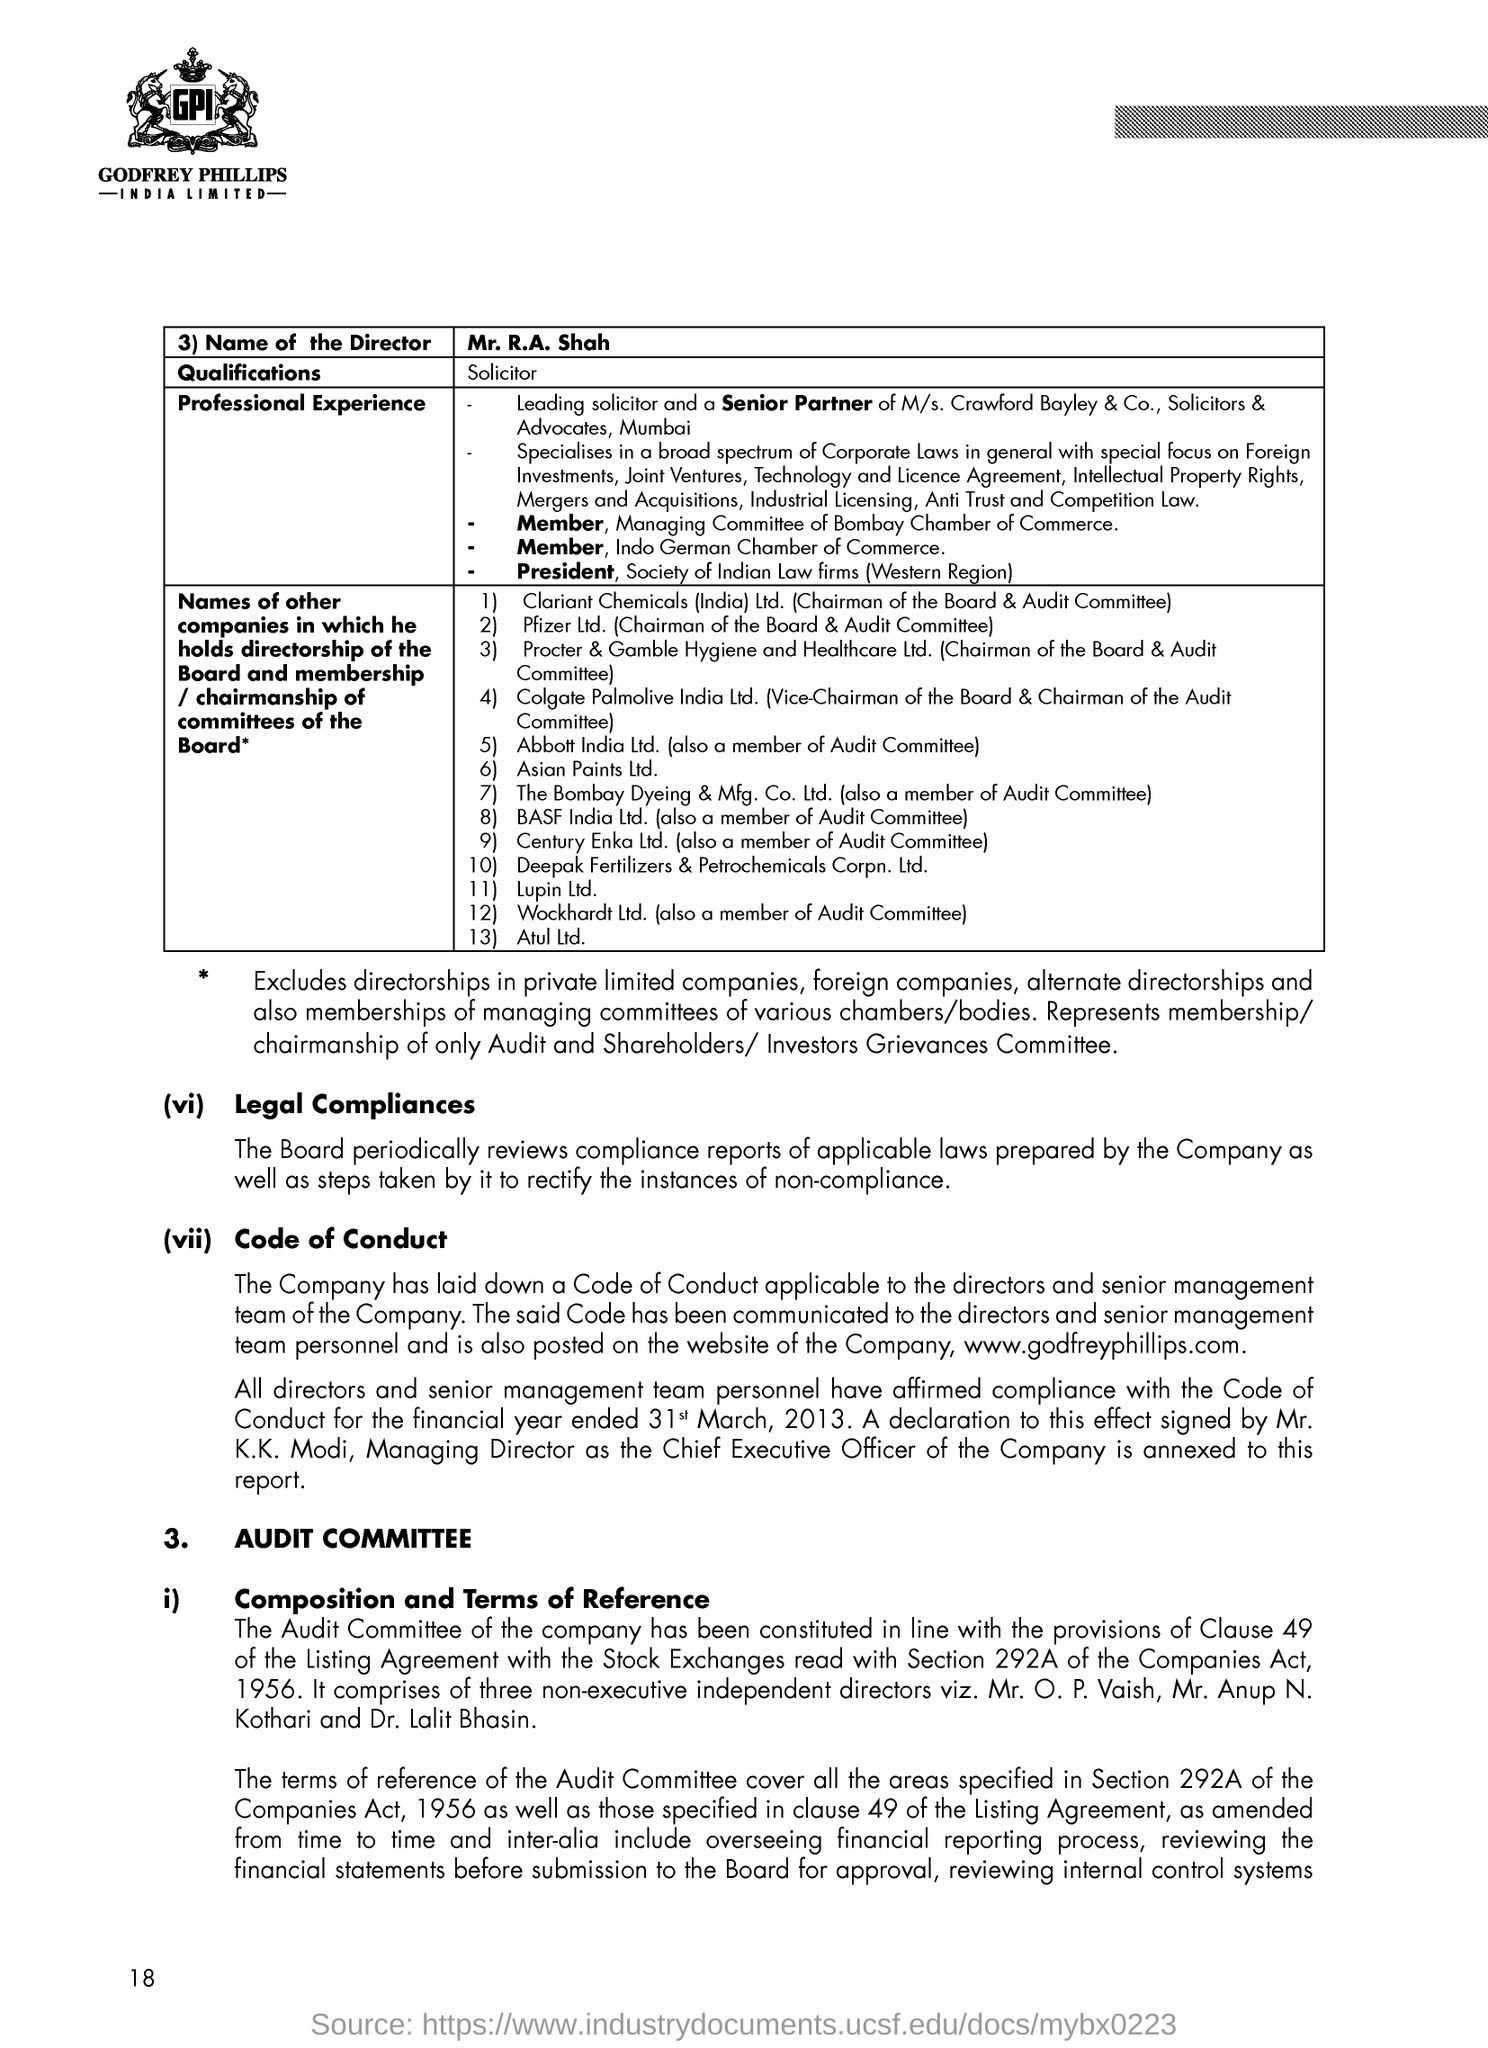What is the name of the Director?
Keep it short and to the point. Mr. R.A. Shah. What is Mr. R.A. Shah's qualification?
Make the answer very short. Solicitor. 